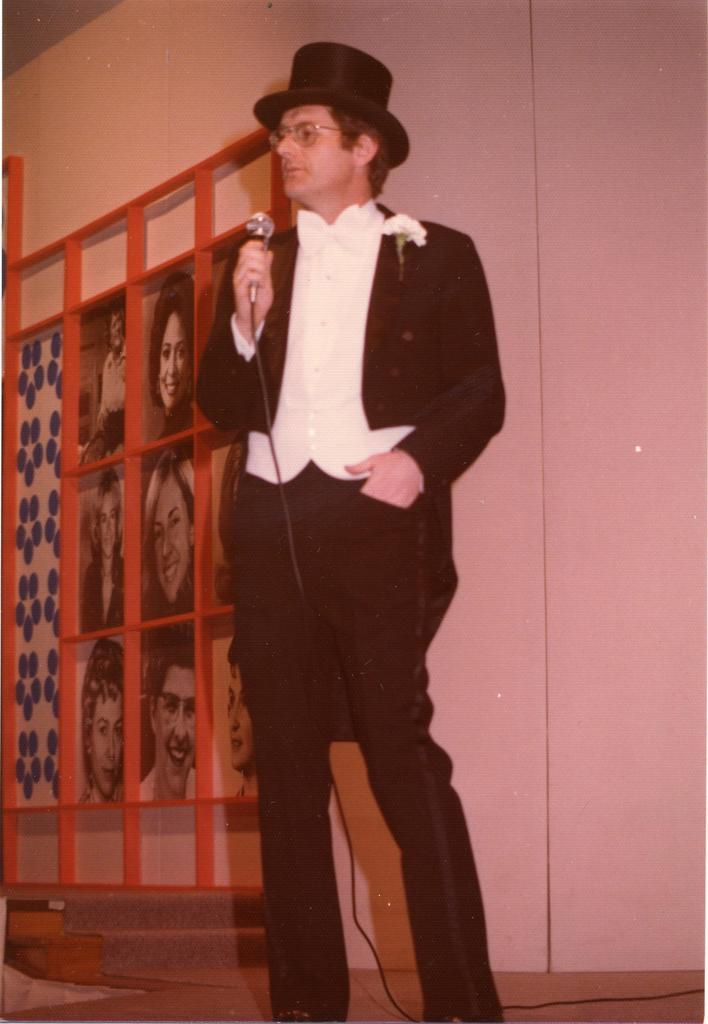What is the person in the image doing? The person is standing in the image and holding a microphone. What is the person wearing? The person is wearing a black and white dress. What can be seen in the background of the image? There are photos in the background of the image. What color is the wall in the image? The wall is white in color. Can you see a coil in the person's hand in the image? No, there is no coil visible in the person's hand in the image; they are holding a microphone. Is there a garden visible in the image? No, there is no garden present in the image. 